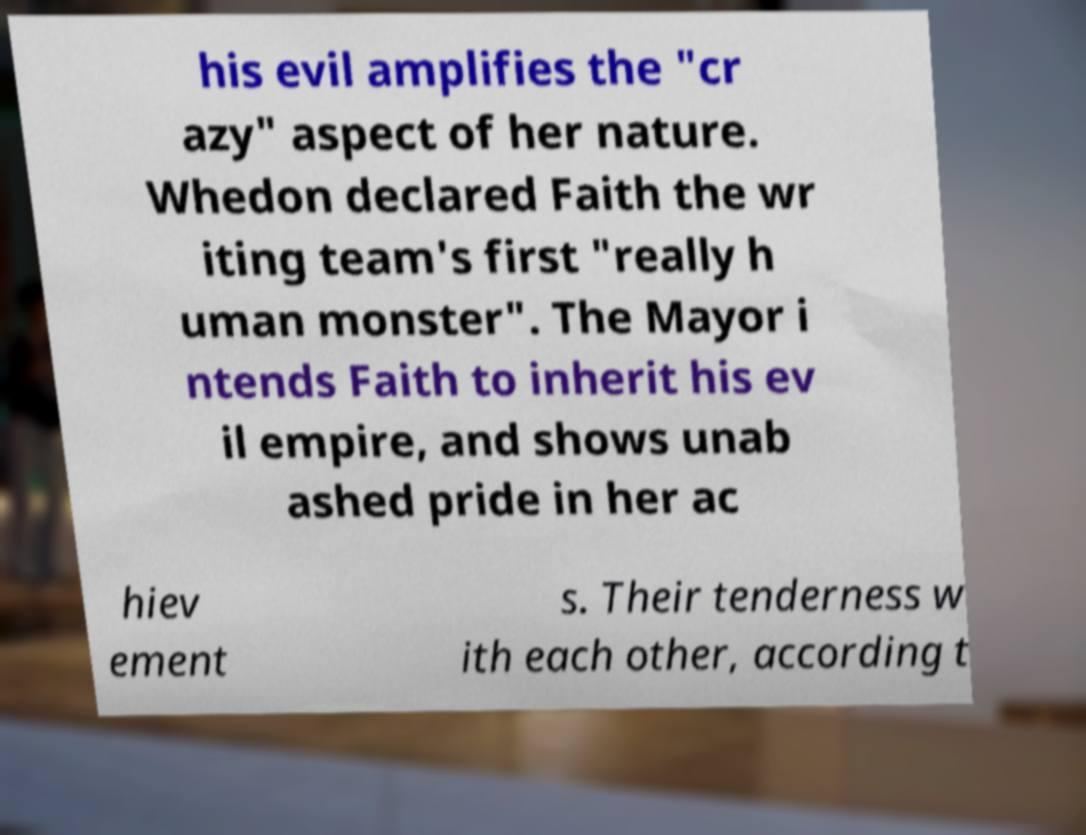What messages or text are displayed in this image? I need them in a readable, typed format. his evil amplifies the "cr azy" aspect of her nature. Whedon declared Faith the wr iting team's first "really h uman monster". The Mayor i ntends Faith to inherit his ev il empire, and shows unab ashed pride in her ac hiev ement s. Their tenderness w ith each other, according t 